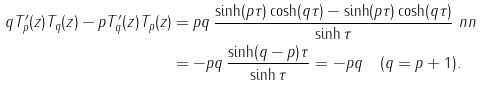<formula> <loc_0><loc_0><loc_500><loc_500>q T _ { p } ^ { \prime } ( z ) T _ { q } ( z ) - p T _ { q } ^ { \prime } ( z ) T _ { p } ( z ) & = p q \, \frac { \sinh ( p \tau ) \cosh ( q \tau ) - \sinh ( p \tau ) \cosh ( q \tau ) } { \sinh \tau } \ n n \\ & = - p q \, \frac { \sinh ( q - p ) \tau } { \sinh \tau } = - p q \quad ( q = p + 1 ) .</formula> 